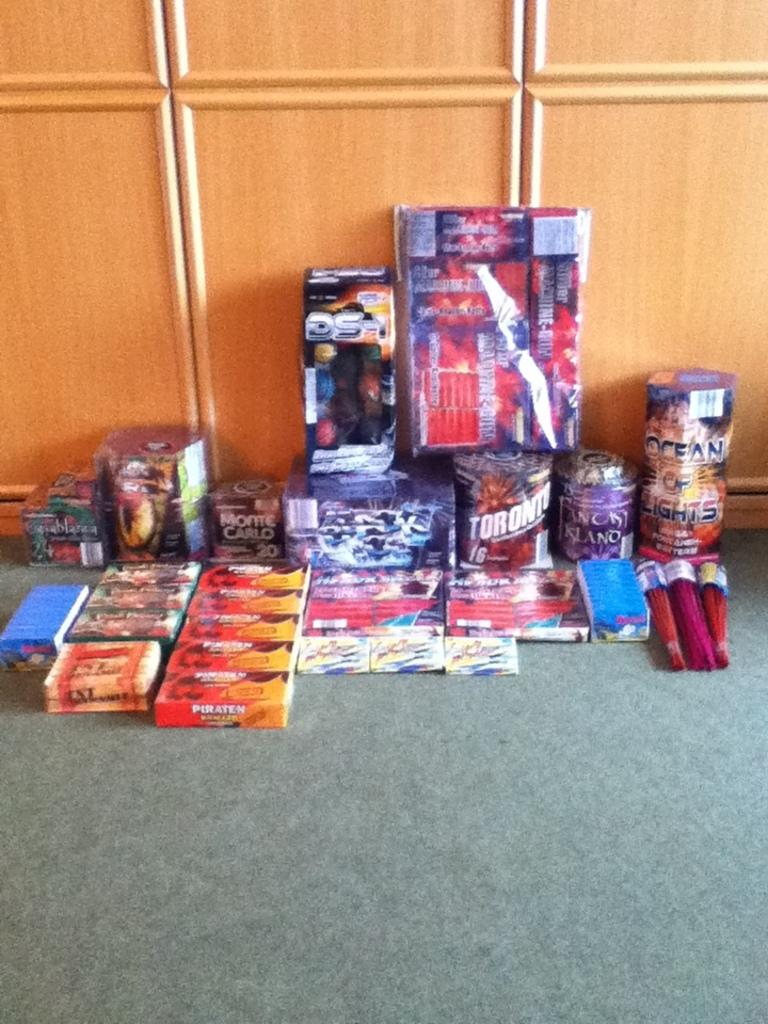What is on the floor in the image? There are objects on the floor in the image. What can be seen in the background of the image? There are cupboards in the background of the image. What type of string is being used to floss the teeth of the crown in the image? There is no string, teeth, or crown present in the image. 